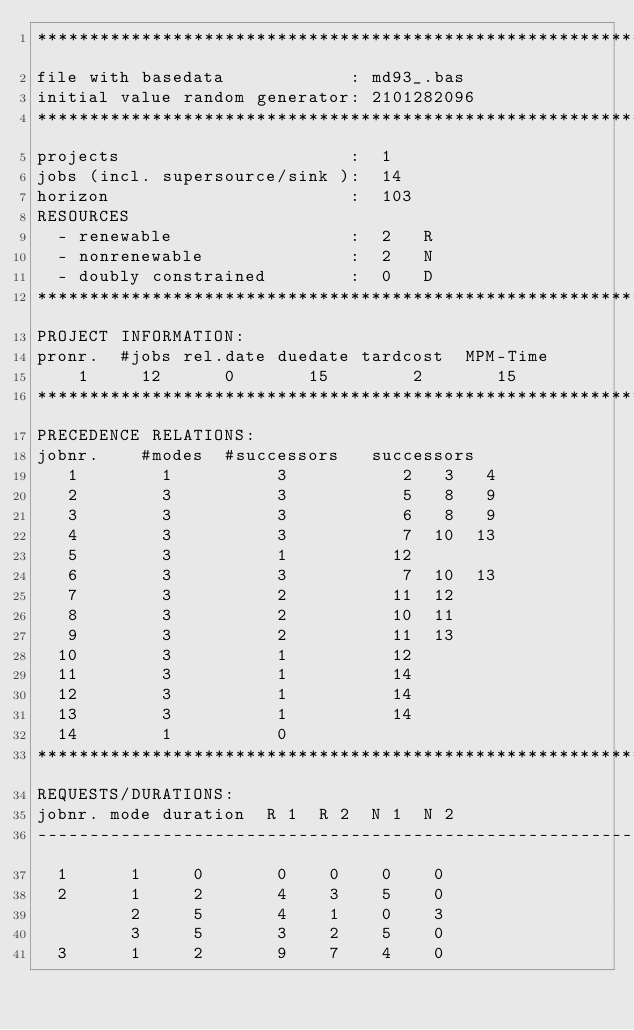<code> <loc_0><loc_0><loc_500><loc_500><_ObjectiveC_>************************************************************************
file with basedata            : md93_.bas
initial value random generator: 2101282096
************************************************************************
projects                      :  1
jobs (incl. supersource/sink ):  14
horizon                       :  103
RESOURCES
  - renewable                 :  2   R
  - nonrenewable              :  2   N
  - doubly constrained        :  0   D
************************************************************************
PROJECT INFORMATION:
pronr.  #jobs rel.date duedate tardcost  MPM-Time
    1     12      0       15        2       15
************************************************************************
PRECEDENCE RELATIONS:
jobnr.    #modes  #successors   successors
   1        1          3           2   3   4
   2        3          3           5   8   9
   3        3          3           6   8   9
   4        3          3           7  10  13
   5        3          1          12
   6        3          3           7  10  13
   7        3          2          11  12
   8        3          2          10  11
   9        3          2          11  13
  10        3          1          12
  11        3          1          14
  12        3          1          14
  13        3          1          14
  14        1          0        
************************************************************************
REQUESTS/DURATIONS:
jobnr. mode duration  R 1  R 2  N 1  N 2
------------------------------------------------------------------------
  1      1     0       0    0    0    0
  2      1     2       4    3    5    0
         2     5       4    1    0    3
         3     5       3    2    5    0
  3      1     2       9    7    4    0</code> 